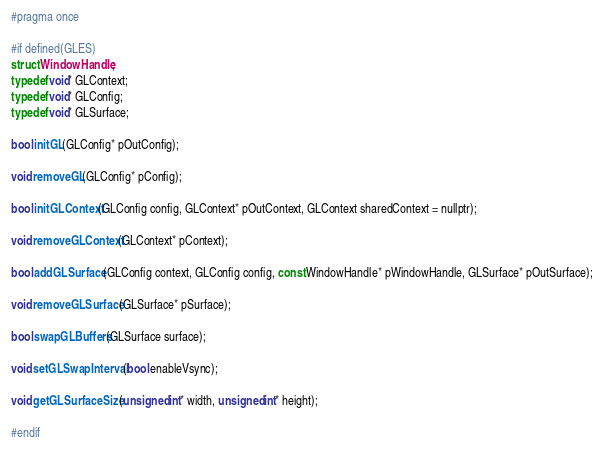Convert code to text. <code><loc_0><loc_0><loc_500><loc_500><_C_>#pragma once

#if defined(GLES)
struct WindowHandle;
typedef void* GLContext;
typedef void* GLConfig;
typedef void* GLSurface;

bool initGL(GLConfig* pOutConfig);

void removeGL(GLConfig* pConfig);

bool initGLContext(GLConfig config, GLContext* pOutContext, GLContext sharedContext = nullptr);

void removeGLContext(GLContext* pContext);

bool addGLSurface(GLConfig context, GLConfig config, const WindowHandle* pWindowHandle, GLSurface* pOutSurface);

void removeGLSurface(GLSurface* pSurface);

bool swapGLBuffers(GLSurface surface);

void setGLSwapInterval(bool enableVsync);

void getGLSurfaceSize(unsigned int* width, unsigned int* height);

#endif</code> 